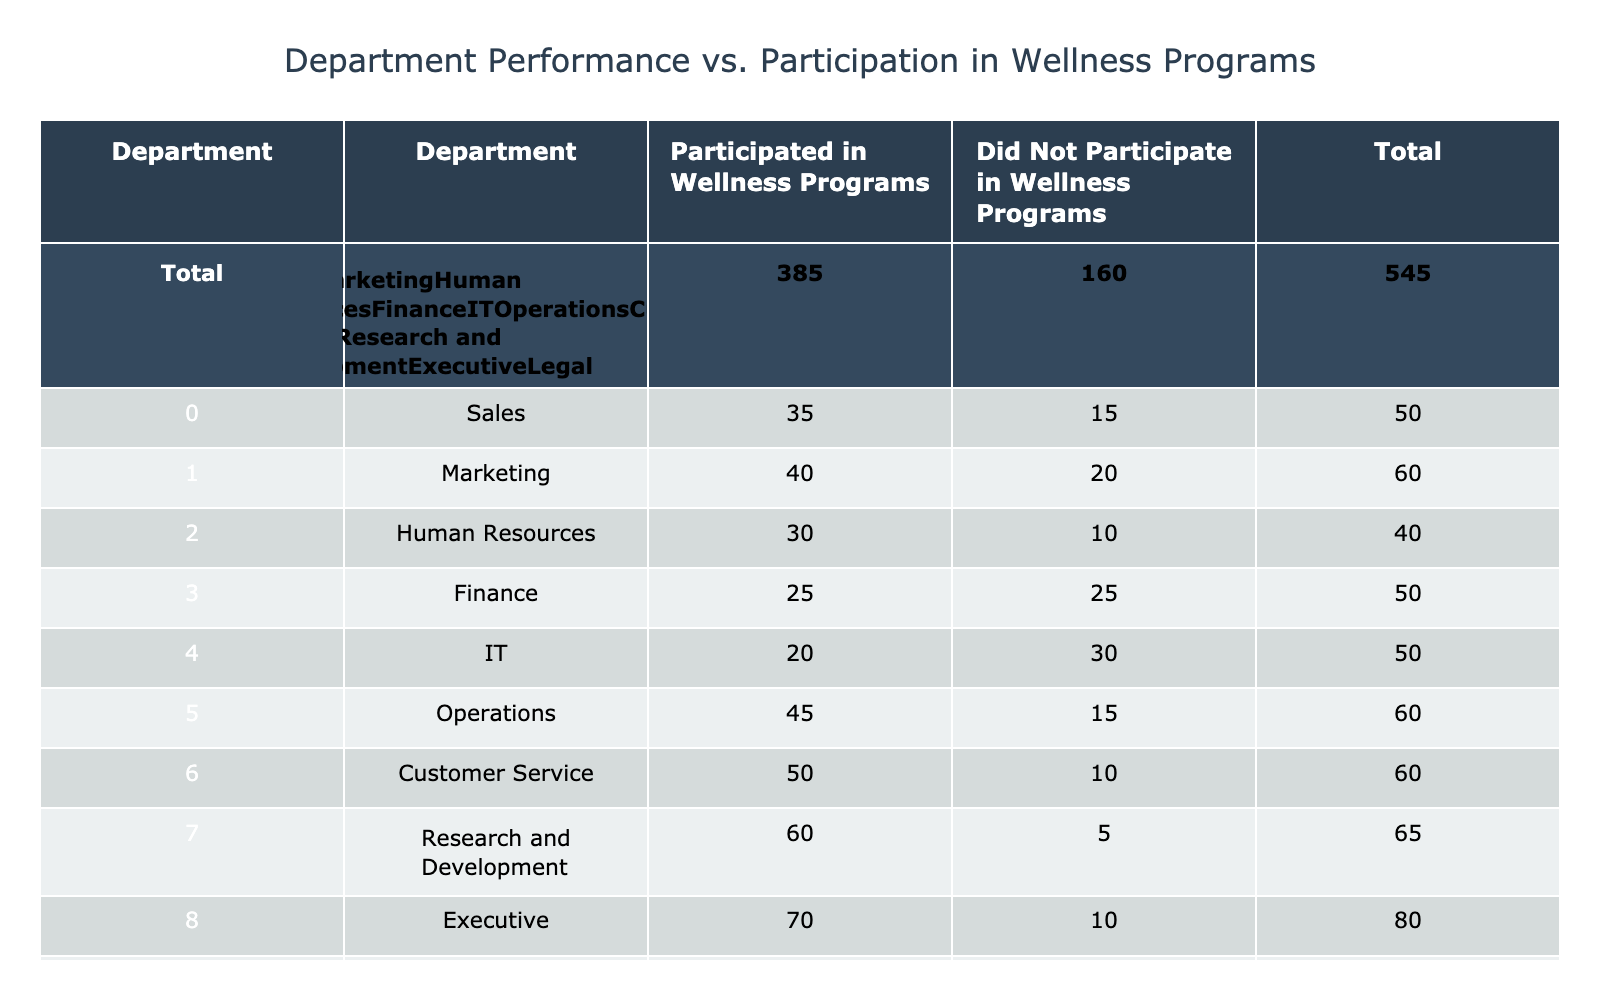What department had the highest participation in wellness programs? The participation numbers are listed in the "Participated in Wellness Programs" column. By examining the values, Research and Development has 60, which is the highest among all departments.
Answer: Research and Development What is the total number of employees who participated in wellness programs across all departments? To find this, we sum the values in the "Participated in Wellness Programs" column: 35 + 40 + 30 + 25 + 20 + 45 + 50 + 60 + 70 + 10 =  415.
Answer: 415 Which department had the lowest number of employees that did not participate in wellness programs? Looking at the "Did Not Participate in Wellness Programs" column, the department with the lowest value is Research and Development with only 5 employees not participating.
Answer: Research and Development Is it true that Finance had the same number of employees participating and not participating in wellness programs? Referring to the table, Finance has 25 employees who participated and also 25 employees who did not participate. Since these numbers are equal, the statement is true.
Answer: True What is the average number of employees across all departments who did not participate in wellness programs? First, we sum the values in the "Did Not Participate in Wellness Programs" column: 15 + 20 + 10 + 25 + 30 + 15 + 10 + 5 + 10 + 20 =  155. There are 10 departments, so the average is 155/10 = 15.5.
Answer: 15.5 Which department had the greatest difference in participation between those who did and did not participate in wellness programs? We calculate the difference for each department by subtracting the "Did Not Participate" value from "Participated" value. The greatest difference is with Operations (45 - 15 = 30) and Customer Service (50 - 10 = 40), making Customer Service the one with the greatest difference.
Answer: Customer Service How many departments had more than 30 employees participate in wellness programs? By examining the "Participated in Wellness Programs" column, we see that Sales, Marketing, Operations, Customer Service, Research and Development, and Executive have more than 30 participants. Counting these gives us 6 departments.
Answer: 6 What is the total number of employees across all departments? We sum the totals for each department: (Participated + Did Not Participate) for each department. Thus, the total is: (35 + 15) + (40 + 20) + (30 + 10) + (25 + 25) + (20 + 30) + (45 + 15) + (50 + 10) + (60 + 5) + (70 + 10) + (10 + 20) = 610.
Answer: 610 